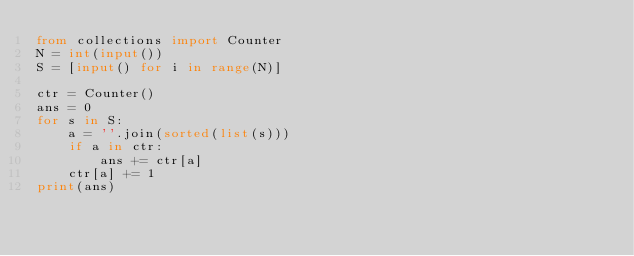Convert code to text. <code><loc_0><loc_0><loc_500><loc_500><_Python_>from collections import Counter
N = int(input())
S = [input() for i in range(N)]

ctr = Counter()
ans = 0
for s in S:
    a = ''.join(sorted(list(s)))
    if a in ctr:
        ans += ctr[a]
    ctr[a] += 1
print(ans)</code> 